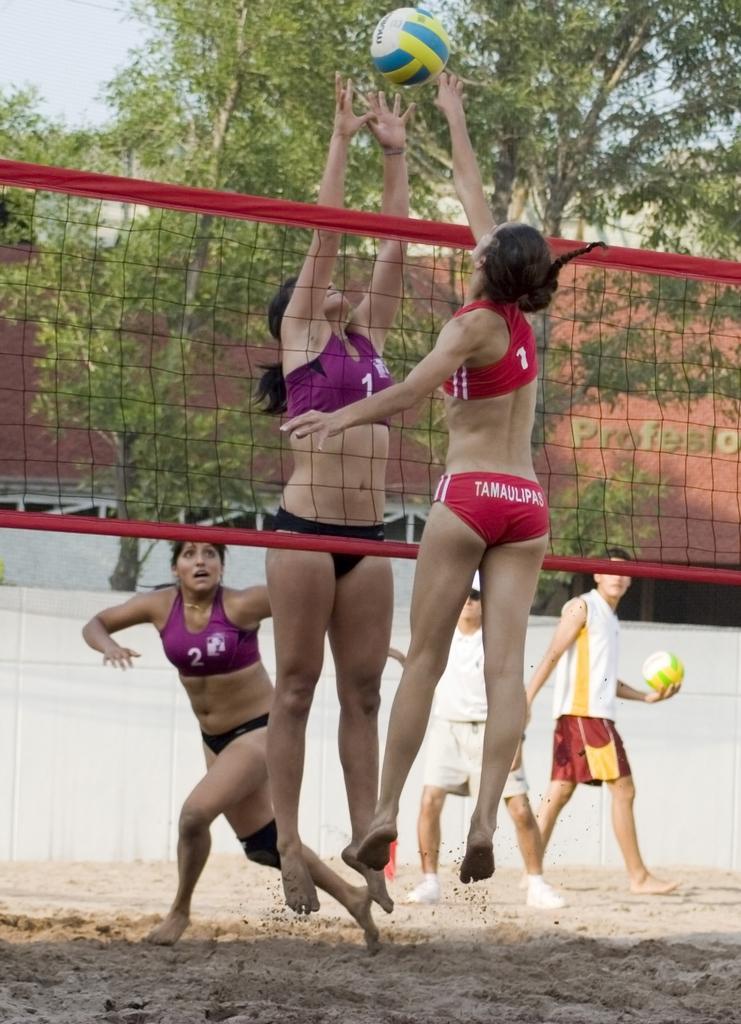Please provide a concise description of this image. In this image there is the sky towards the top of the image, there is the wall, there is text on the wall, there are players playing volleyball, there is a net, there is a man walking, he is holding an object, there is a man standing, there is sand towards the bottom of the image. 